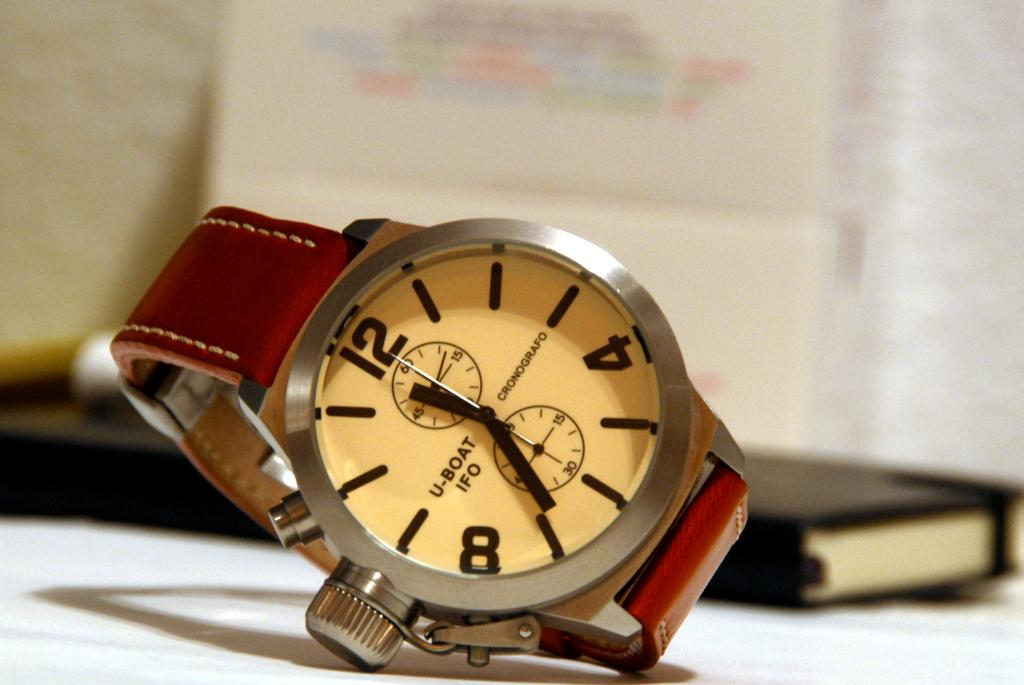Provide a one-sentence caption for the provided image. a watch face with one of the dials pointing at the 12. 